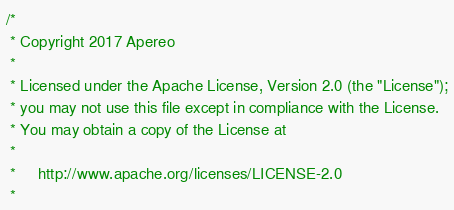Convert code to text. <code><loc_0><loc_0><loc_500><loc_500><_Scala_>/*
 * Copyright 2017 Apereo
 *
 * Licensed under the Apache License, Version 2.0 (the "License");
 * you may not use this file except in compliance with the License.
 * You may obtain a copy of the License at
 *
 *     http://www.apache.org/licenses/LICENSE-2.0
 *</code> 